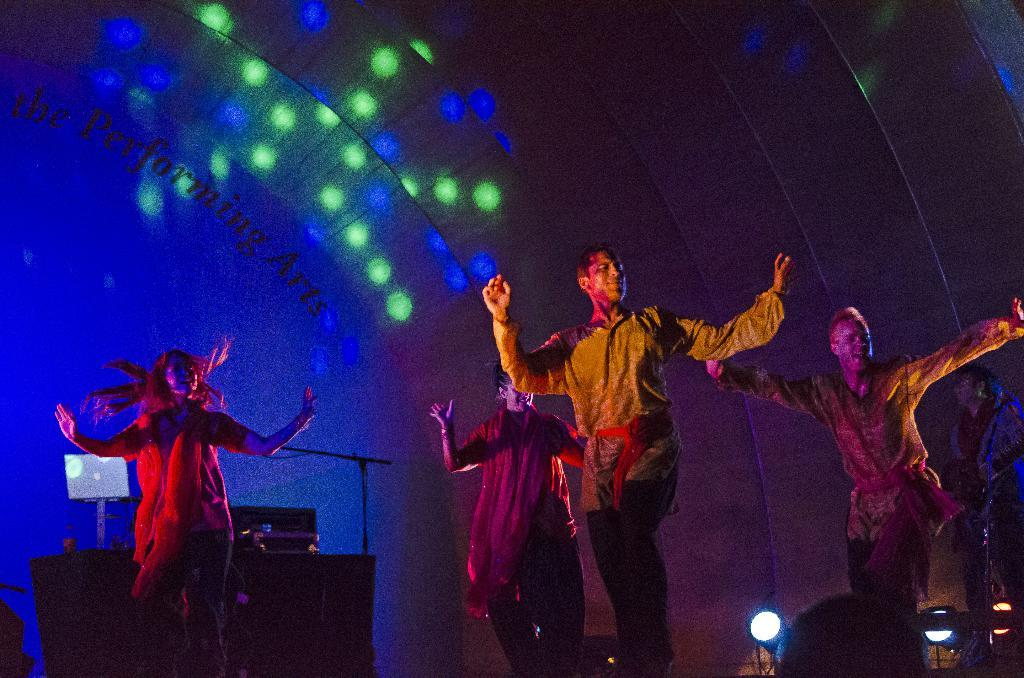What are the people in the image doing? The people are standing on the dais and performing. What equipment can be seen in the background that might be related to their performance? There is a music system, a laptop, a mic, a mic stand, and electric lights in the background. What else is present in the background that might be related to the setting? There is a curtain in the background. What type of game is being played on the coal in the image? There is no game or coal present in the image; it features people performing on a dais with various equipment in the background. What kind of agreement is being discussed by the people in the image? There is no indication of any discussion or agreement in the image; it shows people performing on a dais with various equipment in the background. 